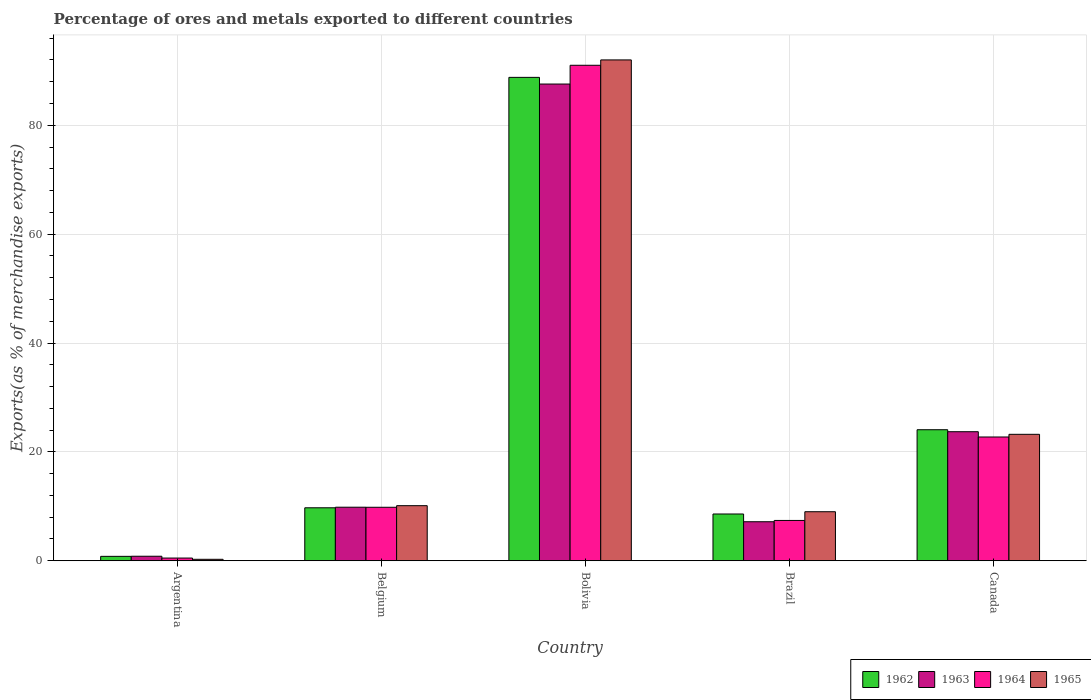How many different coloured bars are there?
Ensure brevity in your answer.  4. Are the number of bars per tick equal to the number of legend labels?
Your answer should be compact. Yes. What is the percentage of exports to different countries in 1962 in Canada?
Keep it short and to the point. 24.07. Across all countries, what is the maximum percentage of exports to different countries in 1965?
Provide a short and direct response. 92. Across all countries, what is the minimum percentage of exports to different countries in 1964?
Offer a very short reply. 0.5. In which country was the percentage of exports to different countries in 1964 minimum?
Make the answer very short. Argentina. What is the total percentage of exports to different countries in 1963 in the graph?
Make the answer very short. 129.12. What is the difference between the percentage of exports to different countries in 1962 in Belgium and that in Canada?
Offer a very short reply. -14.34. What is the difference between the percentage of exports to different countries in 1965 in Bolivia and the percentage of exports to different countries in 1962 in Argentina?
Keep it short and to the point. 91.19. What is the average percentage of exports to different countries in 1962 per country?
Provide a short and direct response. 26.4. What is the difference between the percentage of exports to different countries of/in 1962 and percentage of exports to different countries of/in 1965 in Canada?
Provide a short and direct response. 0.84. What is the ratio of the percentage of exports to different countries in 1964 in Argentina to that in Belgium?
Your response must be concise. 0.05. Is the difference between the percentage of exports to different countries in 1962 in Argentina and Brazil greater than the difference between the percentage of exports to different countries in 1965 in Argentina and Brazil?
Offer a very short reply. Yes. What is the difference between the highest and the second highest percentage of exports to different countries in 1963?
Your response must be concise. -13.87. What is the difference between the highest and the lowest percentage of exports to different countries in 1965?
Your answer should be compact. 91.73. Is the sum of the percentage of exports to different countries in 1965 in Argentina and Canada greater than the maximum percentage of exports to different countries in 1963 across all countries?
Give a very brief answer. No. Is it the case that in every country, the sum of the percentage of exports to different countries in 1962 and percentage of exports to different countries in 1964 is greater than the sum of percentage of exports to different countries in 1965 and percentage of exports to different countries in 1963?
Offer a very short reply. No. What does the 1st bar from the left in Belgium represents?
Your answer should be very brief. 1962. How many bars are there?
Your response must be concise. 20. What is the difference between two consecutive major ticks on the Y-axis?
Provide a succinct answer. 20. Does the graph contain any zero values?
Your answer should be very brief. No. How many legend labels are there?
Make the answer very short. 4. How are the legend labels stacked?
Make the answer very short. Horizontal. What is the title of the graph?
Make the answer very short. Percentage of ores and metals exported to different countries. What is the label or title of the Y-axis?
Keep it short and to the point. Exports(as % of merchandise exports). What is the Exports(as % of merchandise exports) of 1962 in Argentina?
Ensure brevity in your answer.  0.81. What is the Exports(as % of merchandise exports) in 1963 in Argentina?
Your answer should be compact. 0.83. What is the Exports(as % of merchandise exports) of 1964 in Argentina?
Your answer should be compact. 0.5. What is the Exports(as % of merchandise exports) of 1965 in Argentina?
Offer a terse response. 0.27. What is the Exports(as % of merchandise exports) in 1962 in Belgium?
Your answer should be compact. 9.73. What is the Exports(as % of merchandise exports) in 1963 in Belgium?
Provide a short and direct response. 9.84. What is the Exports(as % of merchandise exports) of 1964 in Belgium?
Offer a terse response. 9.83. What is the Exports(as % of merchandise exports) in 1965 in Belgium?
Give a very brief answer. 10.12. What is the Exports(as % of merchandise exports) in 1962 in Bolivia?
Your answer should be very brief. 88.79. What is the Exports(as % of merchandise exports) of 1963 in Bolivia?
Make the answer very short. 87.57. What is the Exports(as % of merchandise exports) of 1964 in Bolivia?
Give a very brief answer. 91.02. What is the Exports(as % of merchandise exports) of 1965 in Bolivia?
Your response must be concise. 92. What is the Exports(as % of merchandise exports) in 1962 in Brazil?
Ensure brevity in your answer.  8.59. What is the Exports(as % of merchandise exports) of 1963 in Brazil?
Offer a very short reply. 7.17. What is the Exports(as % of merchandise exports) in 1964 in Brazil?
Keep it short and to the point. 7.41. What is the Exports(as % of merchandise exports) of 1965 in Brazil?
Make the answer very short. 9.01. What is the Exports(as % of merchandise exports) in 1962 in Canada?
Make the answer very short. 24.07. What is the Exports(as % of merchandise exports) of 1963 in Canada?
Provide a succinct answer. 23.71. What is the Exports(as % of merchandise exports) of 1964 in Canada?
Ensure brevity in your answer.  22.74. What is the Exports(as % of merchandise exports) of 1965 in Canada?
Provide a succinct answer. 23.23. Across all countries, what is the maximum Exports(as % of merchandise exports) in 1962?
Ensure brevity in your answer.  88.79. Across all countries, what is the maximum Exports(as % of merchandise exports) of 1963?
Offer a very short reply. 87.57. Across all countries, what is the maximum Exports(as % of merchandise exports) in 1964?
Your response must be concise. 91.02. Across all countries, what is the maximum Exports(as % of merchandise exports) of 1965?
Keep it short and to the point. 92. Across all countries, what is the minimum Exports(as % of merchandise exports) in 1962?
Make the answer very short. 0.81. Across all countries, what is the minimum Exports(as % of merchandise exports) of 1963?
Your answer should be compact. 0.83. Across all countries, what is the minimum Exports(as % of merchandise exports) of 1964?
Provide a short and direct response. 0.5. Across all countries, what is the minimum Exports(as % of merchandise exports) in 1965?
Your answer should be compact. 0.27. What is the total Exports(as % of merchandise exports) in 1962 in the graph?
Give a very brief answer. 132. What is the total Exports(as % of merchandise exports) of 1963 in the graph?
Provide a succinct answer. 129.12. What is the total Exports(as % of merchandise exports) of 1964 in the graph?
Ensure brevity in your answer.  131.49. What is the total Exports(as % of merchandise exports) of 1965 in the graph?
Your response must be concise. 134.63. What is the difference between the Exports(as % of merchandise exports) of 1962 in Argentina and that in Belgium?
Provide a succinct answer. -8.92. What is the difference between the Exports(as % of merchandise exports) in 1963 in Argentina and that in Belgium?
Ensure brevity in your answer.  -9. What is the difference between the Exports(as % of merchandise exports) of 1964 in Argentina and that in Belgium?
Make the answer very short. -9.33. What is the difference between the Exports(as % of merchandise exports) in 1965 in Argentina and that in Belgium?
Keep it short and to the point. -9.85. What is the difference between the Exports(as % of merchandise exports) of 1962 in Argentina and that in Bolivia?
Your response must be concise. -87.98. What is the difference between the Exports(as % of merchandise exports) of 1963 in Argentina and that in Bolivia?
Keep it short and to the point. -86.74. What is the difference between the Exports(as % of merchandise exports) of 1964 in Argentina and that in Bolivia?
Offer a very short reply. -90.52. What is the difference between the Exports(as % of merchandise exports) in 1965 in Argentina and that in Bolivia?
Make the answer very short. -91.73. What is the difference between the Exports(as % of merchandise exports) of 1962 in Argentina and that in Brazil?
Offer a terse response. -7.78. What is the difference between the Exports(as % of merchandise exports) in 1963 in Argentina and that in Brazil?
Your answer should be very brief. -6.34. What is the difference between the Exports(as % of merchandise exports) in 1964 in Argentina and that in Brazil?
Give a very brief answer. -6.91. What is the difference between the Exports(as % of merchandise exports) of 1965 in Argentina and that in Brazil?
Ensure brevity in your answer.  -8.74. What is the difference between the Exports(as % of merchandise exports) of 1962 in Argentina and that in Canada?
Your response must be concise. -23.26. What is the difference between the Exports(as % of merchandise exports) in 1963 in Argentina and that in Canada?
Offer a terse response. -22.87. What is the difference between the Exports(as % of merchandise exports) in 1964 in Argentina and that in Canada?
Make the answer very short. -22.24. What is the difference between the Exports(as % of merchandise exports) in 1965 in Argentina and that in Canada?
Make the answer very short. -22.96. What is the difference between the Exports(as % of merchandise exports) in 1962 in Belgium and that in Bolivia?
Make the answer very short. -79.06. What is the difference between the Exports(as % of merchandise exports) in 1963 in Belgium and that in Bolivia?
Your response must be concise. -77.73. What is the difference between the Exports(as % of merchandise exports) of 1964 in Belgium and that in Bolivia?
Ensure brevity in your answer.  -81.19. What is the difference between the Exports(as % of merchandise exports) of 1965 in Belgium and that in Bolivia?
Offer a very short reply. -81.88. What is the difference between the Exports(as % of merchandise exports) in 1962 in Belgium and that in Brazil?
Keep it short and to the point. 1.14. What is the difference between the Exports(as % of merchandise exports) of 1963 in Belgium and that in Brazil?
Provide a short and direct response. 2.67. What is the difference between the Exports(as % of merchandise exports) of 1964 in Belgium and that in Brazil?
Keep it short and to the point. 2.42. What is the difference between the Exports(as % of merchandise exports) of 1965 in Belgium and that in Brazil?
Your answer should be very brief. 1.11. What is the difference between the Exports(as % of merchandise exports) of 1962 in Belgium and that in Canada?
Ensure brevity in your answer.  -14.34. What is the difference between the Exports(as % of merchandise exports) in 1963 in Belgium and that in Canada?
Provide a succinct answer. -13.87. What is the difference between the Exports(as % of merchandise exports) in 1964 in Belgium and that in Canada?
Keep it short and to the point. -12.91. What is the difference between the Exports(as % of merchandise exports) in 1965 in Belgium and that in Canada?
Provide a short and direct response. -13.11. What is the difference between the Exports(as % of merchandise exports) of 1962 in Bolivia and that in Brazil?
Your response must be concise. 80.2. What is the difference between the Exports(as % of merchandise exports) of 1963 in Bolivia and that in Brazil?
Make the answer very short. 80.4. What is the difference between the Exports(as % of merchandise exports) of 1964 in Bolivia and that in Brazil?
Ensure brevity in your answer.  83.61. What is the difference between the Exports(as % of merchandise exports) in 1965 in Bolivia and that in Brazil?
Provide a short and direct response. 82.99. What is the difference between the Exports(as % of merchandise exports) in 1962 in Bolivia and that in Canada?
Your answer should be compact. 64.72. What is the difference between the Exports(as % of merchandise exports) of 1963 in Bolivia and that in Canada?
Keep it short and to the point. 63.86. What is the difference between the Exports(as % of merchandise exports) of 1964 in Bolivia and that in Canada?
Your answer should be very brief. 68.28. What is the difference between the Exports(as % of merchandise exports) of 1965 in Bolivia and that in Canada?
Give a very brief answer. 68.77. What is the difference between the Exports(as % of merchandise exports) in 1962 in Brazil and that in Canada?
Your response must be concise. -15.48. What is the difference between the Exports(as % of merchandise exports) of 1963 in Brazil and that in Canada?
Offer a very short reply. -16.54. What is the difference between the Exports(as % of merchandise exports) in 1964 in Brazil and that in Canada?
Ensure brevity in your answer.  -15.33. What is the difference between the Exports(as % of merchandise exports) in 1965 in Brazil and that in Canada?
Your answer should be very brief. -14.22. What is the difference between the Exports(as % of merchandise exports) in 1962 in Argentina and the Exports(as % of merchandise exports) in 1963 in Belgium?
Provide a succinct answer. -9.02. What is the difference between the Exports(as % of merchandise exports) of 1962 in Argentina and the Exports(as % of merchandise exports) of 1964 in Belgium?
Provide a short and direct response. -9.01. What is the difference between the Exports(as % of merchandise exports) in 1962 in Argentina and the Exports(as % of merchandise exports) in 1965 in Belgium?
Give a very brief answer. -9.31. What is the difference between the Exports(as % of merchandise exports) in 1963 in Argentina and the Exports(as % of merchandise exports) in 1964 in Belgium?
Your answer should be compact. -8.99. What is the difference between the Exports(as % of merchandise exports) in 1963 in Argentina and the Exports(as % of merchandise exports) in 1965 in Belgium?
Give a very brief answer. -9.29. What is the difference between the Exports(as % of merchandise exports) of 1964 in Argentina and the Exports(as % of merchandise exports) of 1965 in Belgium?
Ensure brevity in your answer.  -9.62. What is the difference between the Exports(as % of merchandise exports) in 1962 in Argentina and the Exports(as % of merchandise exports) in 1963 in Bolivia?
Your response must be concise. -86.76. What is the difference between the Exports(as % of merchandise exports) in 1962 in Argentina and the Exports(as % of merchandise exports) in 1964 in Bolivia?
Your answer should be very brief. -90.2. What is the difference between the Exports(as % of merchandise exports) in 1962 in Argentina and the Exports(as % of merchandise exports) in 1965 in Bolivia?
Make the answer very short. -91.19. What is the difference between the Exports(as % of merchandise exports) of 1963 in Argentina and the Exports(as % of merchandise exports) of 1964 in Bolivia?
Ensure brevity in your answer.  -90.18. What is the difference between the Exports(as % of merchandise exports) of 1963 in Argentina and the Exports(as % of merchandise exports) of 1965 in Bolivia?
Your answer should be very brief. -91.17. What is the difference between the Exports(as % of merchandise exports) in 1964 in Argentina and the Exports(as % of merchandise exports) in 1965 in Bolivia?
Provide a short and direct response. -91.5. What is the difference between the Exports(as % of merchandise exports) of 1962 in Argentina and the Exports(as % of merchandise exports) of 1963 in Brazil?
Keep it short and to the point. -6.36. What is the difference between the Exports(as % of merchandise exports) of 1962 in Argentina and the Exports(as % of merchandise exports) of 1964 in Brazil?
Your answer should be very brief. -6.59. What is the difference between the Exports(as % of merchandise exports) in 1962 in Argentina and the Exports(as % of merchandise exports) in 1965 in Brazil?
Give a very brief answer. -8.2. What is the difference between the Exports(as % of merchandise exports) in 1963 in Argentina and the Exports(as % of merchandise exports) in 1964 in Brazil?
Offer a very short reply. -6.57. What is the difference between the Exports(as % of merchandise exports) in 1963 in Argentina and the Exports(as % of merchandise exports) in 1965 in Brazil?
Your answer should be very brief. -8.18. What is the difference between the Exports(as % of merchandise exports) of 1964 in Argentina and the Exports(as % of merchandise exports) of 1965 in Brazil?
Give a very brief answer. -8.51. What is the difference between the Exports(as % of merchandise exports) in 1962 in Argentina and the Exports(as % of merchandise exports) in 1963 in Canada?
Offer a terse response. -22.89. What is the difference between the Exports(as % of merchandise exports) of 1962 in Argentina and the Exports(as % of merchandise exports) of 1964 in Canada?
Provide a succinct answer. -21.92. What is the difference between the Exports(as % of merchandise exports) in 1962 in Argentina and the Exports(as % of merchandise exports) in 1965 in Canada?
Make the answer very short. -22.41. What is the difference between the Exports(as % of merchandise exports) of 1963 in Argentina and the Exports(as % of merchandise exports) of 1964 in Canada?
Provide a succinct answer. -21.9. What is the difference between the Exports(as % of merchandise exports) in 1963 in Argentina and the Exports(as % of merchandise exports) in 1965 in Canada?
Make the answer very short. -22.39. What is the difference between the Exports(as % of merchandise exports) in 1964 in Argentina and the Exports(as % of merchandise exports) in 1965 in Canada?
Keep it short and to the point. -22.73. What is the difference between the Exports(as % of merchandise exports) of 1962 in Belgium and the Exports(as % of merchandise exports) of 1963 in Bolivia?
Offer a very short reply. -77.84. What is the difference between the Exports(as % of merchandise exports) in 1962 in Belgium and the Exports(as % of merchandise exports) in 1964 in Bolivia?
Keep it short and to the point. -81.28. What is the difference between the Exports(as % of merchandise exports) in 1962 in Belgium and the Exports(as % of merchandise exports) in 1965 in Bolivia?
Your answer should be compact. -82.27. What is the difference between the Exports(as % of merchandise exports) of 1963 in Belgium and the Exports(as % of merchandise exports) of 1964 in Bolivia?
Keep it short and to the point. -81.18. What is the difference between the Exports(as % of merchandise exports) of 1963 in Belgium and the Exports(as % of merchandise exports) of 1965 in Bolivia?
Offer a very short reply. -82.16. What is the difference between the Exports(as % of merchandise exports) of 1964 in Belgium and the Exports(as % of merchandise exports) of 1965 in Bolivia?
Give a very brief answer. -82.17. What is the difference between the Exports(as % of merchandise exports) of 1962 in Belgium and the Exports(as % of merchandise exports) of 1963 in Brazil?
Your answer should be very brief. 2.56. What is the difference between the Exports(as % of merchandise exports) of 1962 in Belgium and the Exports(as % of merchandise exports) of 1964 in Brazil?
Your answer should be compact. 2.33. What is the difference between the Exports(as % of merchandise exports) of 1962 in Belgium and the Exports(as % of merchandise exports) of 1965 in Brazil?
Keep it short and to the point. 0.72. What is the difference between the Exports(as % of merchandise exports) in 1963 in Belgium and the Exports(as % of merchandise exports) in 1964 in Brazil?
Your answer should be compact. 2.43. What is the difference between the Exports(as % of merchandise exports) in 1963 in Belgium and the Exports(as % of merchandise exports) in 1965 in Brazil?
Offer a very short reply. 0.83. What is the difference between the Exports(as % of merchandise exports) of 1964 in Belgium and the Exports(as % of merchandise exports) of 1965 in Brazil?
Give a very brief answer. 0.82. What is the difference between the Exports(as % of merchandise exports) in 1962 in Belgium and the Exports(as % of merchandise exports) in 1963 in Canada?
Give a very brief answer. -13.97. What is the difference between the Exports(as % of merchandise exports) in 1962 in Belgium and the Exports(as % of merchandise exports) in 1964 in Canada?
Provide a short and direct response. -13. What is the difference between the Exports(as % of merchandise exports) of 1962 in Belgium and the Exports(as % of merchandise exports) of 1965 in Canada?
Provide a succinct answer. -13.49. What is the difference between the Exports(as % of merchandise exports) in 1963 in Belgium and the Exports(as % of merchandise exports) in 1964 in Canada?
Keep it short and to the point. -12.9. What is the difference between the Exports(as % of merchandise exports) in 1963 in Belgium and the Exports(as % of merchandise exports) in 1965 in Canada?
Provide a succinct answer. -13.39. What is the difference between the Exports(as % of merchandise exports) in 1964 in Belgium and the Exports(as % of merchandise exports) in 1965 in Canada?
Offer a terse response. -13.4. What is the difference between the Exports(as % of merchandise exports) of 1962 in Bolivia and the Exports(as % of merchandise exports) of 1963 in Brazil?
Give a very brief answer. 81.62. What is the difference between the Exports(as % of merchandise exports) in 1962 in Bolivia and the Exports(as % of merchandise exports) in 1964 in Brazil?
Your answer should be compact. 81.39. What is the difference between the Exports(as % of merchandise exports) of 1962 in Bolivia and the Exports(as % of merchandise exports) of 1965 in Brazil?
Make the answer very short. 79.78. What is the difference between the Exports(as % of merchandise exports) of 1963 in Bolivia and the Exports(as % of merchandise exports) of 1964 in Brazil?
Make the answer very short. 80.16. What is the difference between the Exports(as % of merchandise exports) in 1963 in Bolivia and the Exports(as % of merchandise exports) in 1965 in Brazil?
Make the answer very short. 78.56. What is the difference between the Exports(as % of merchandise exports) of 1964 in Bolivia and the Exports(as % of merchandise exports) of 1965 in Brazil?
Make the answer very short. 82.01. What is the difference between the Exports(as % of merchandise exports) in 1962 in Bolivia and the Exports(as % of merchandise exports) in 1963 in Canada?
Offer a very short reply. 65.09. What is the difference between the Exports(as % of merchandise exports) of 1962 in Bolivia and the Exports(as % of merchandise exports) of 1964 in Canada?
Your answer should be very brief. 66.06. What is the difference between the Exports(as % of merchandise exports) in 1962 in Bolivia and the Exports(as % of merchandise exports) in 1965 in Canada?
Provide a succinct answer. 65.57. What is the difference between the Exports(as % of merchandise exports) in 1963 in Bolivia and the Exports(as % of merchandise exports) in 1964 in Canada?
Provide a succinct answer. 64.83. What is the difference between the Exports(as % of merchandise exports) of 1963 in Bolivia and the Exports(as % of merchandise exports) of 1965 in Canada?
Your response must be concise. 64.34. What is the difference between the Exports(as % of merchandise exports) of 1964 in Bolivia and the Exports(as % of merchandise exports) of 1965 in Canada?
Your answer should be compact. 67.79. What is the difference between the Exports(as % of merchandise exports) of 1962 in Brazil and the Exports(as % of merchandise exports) of 1963 in Canada?
Your response must be concise. -15.11. What is the difference between the Exports(as % of merchandise exports) of 1962 in Brazil and the Exports(as % of merchandise exports) of 1964 in Canada?
Your answer should be compact. -14.15. What is the difference between the Exports(as % of merchandise exports) in 1962 in Brazil and the Exports(as % of merchandise exports) in 1965 in Canada?
Your response must be concise. -14.64. What is the difference between the Exports(as % of merchandise exports) of 1963 in Brazil and the Exports(as % of merchandise exports) of 1964 in Canada?
Keep it short and to the point. -15.57. What is the difference between the Exports(as % of merchandise exports) of 1963 in Brazil and the Exports(as % of merchandise exports) of 1965 in Canada?
Provide a short and direct response. -16.06. What is the difference between the Exports(as % of merchandise exports) in 1964 in Brazil and the Exports(as % of merchandise exports) in 1965 in Canada?
Your answer should be very brief. -15.82. What is the average Exports(as % of merchandise exports) in 1962 per country?
Your response must be concise. 26.4. What is the average Exports(as % of merchandise exports) of 1963 per country?
Offer a very short reply. 25.82. What is the average Exports(as % of merchandise exports) in 1964 per country?
Give a very brief answer. 26.3. What is the average Exports(as % of merchandise exports) of 1965 per country?
Your response must be concise. 26.93. What is the difference between the Exports(as % of merchandise exports) in 1962 and Exports(as % of merchandise exports) in 1963 in Argentina?
Give a very brief answer. -0.02. What is the difference between the Exports(as % of merchandise exports) of 1962 and Exports(as % of merchandise exports) of 1964 in Argentina?
Give a very brief answer. 0.31. What is the difference between the Exports(as % of merchandise exports) of 1962 and Exports(as % of merchandise exports) of 1965 in Argentina?
Your answer should be compact. 0.54. What is the difference between the Exports(as % of merchandise exports) of 1963 and Exports(as % of merchandise exports) of 1964 in Argentina?
Ensure brevity in your answer.  0.33. What is the difference between the Exports(as % of merchandise exports) of 1963 and Exports(as % of merchandise exports) of 1965 in Argentina?
Provide a short and direct response. 0.56. What is the difference between the Exports(as % of merchandise exports) of 1964 and Exports(as % of merchandise exports) of 1965 in Argentina?
Give a very brief answer. 0.23. What is the difference between the Exports(as % of merchandise exports) in 1962 and Exports(as % of merchandise exports) in 1963 in Belgium?
Give a very brief answer. -0.1. What is the difference between the Exports(as % of merchandise exports) of 1962 and Exports(as % of merchandise exports) of 1964 in Belgium?
Your answer should be very brief. -0.09. What is the difference between the Exports(as % of merchandise exports) of 1962 and Exports(as % of merchandise exports) of 1965 in Belgium?
Your answer should be compact. -0.39. What is the difference between the Exports(as % of merchandise exports) in 1963 and Exports(as % of merchandise exports) in 1964 in Belgium?
Provide a succinct answer. 0.01. What is the difference between the Exports(as % of merchandise exports) of 1963 and Exports(as % of merchandise exports) of 1965 in Belgium?
Keep it short and to the point. -0.28. What is the difference between the Exports(as % of merchandise exports) of 1964 and Exports(as % of merchandise exports) of 1965 in Belgium?
Provide a short and direct response. -0.29. What is the difference between the Exports(as % of merchandise exports) of 1962 and Exports(as % of merchandise exports) of 1963 in Bolivia?
Ensure brevity in your answer.  1.22. What is the difference between the Exports(as % of merchandise exports) in 1962 and Exports(as % of merchandise exports) in 1964 in Bolivia?
Give a very brief answer. -2.22. What is the difference between the Exports(as % of merchandise exports) of 1962 and Exports(as % of merchandise exports) of 1965 in Bolivia?
Provide a succinct answer. -3.21. What is the difference between the Exports(as % of merchandise exports) in 1963 and Exports(as % of merchandise exports) in 1964 in Bolivia?
Ensure brevity in your answer.  -3.45. What is the difference between the Exports(as % of merchandise exports) in 1963 and Exports(as % of merchandise exports) in 1965 in Bolivia?
Provide a short and direct response. -4.43. What is the difference between the Exports(as % of merchandise exports) in 1964 and Exports(as % of merchandise exports) in 1965 in Bolivia?
Ensure brevity in your answer.  -0.98. What is the difference between the Exports(as % of merchandise exports) in 1962 and Exports(as % of merchandise exports) in 1963 in Brazil?
Keep it short and to the point. 1.42. What is the difference between the Exports(as % of merchandise exports) of 1962 and Exports(as % of merchandise exports) of 1964 in Brazil?
Your response must be concise. 1.18. What is the difference between the Exports(as % of merchandise exports) in 1962 and Exports(as % of merchandise exports) in 1965 in Brazil?
Offer a terse response. -0.42. What is the difference between the Exports(as % of merchandise exports) of 1963 and Exports(as % of merchandise exports) of 1964 in Brazil?
Offer a terse response. -0.24. What is the difference between the Exports(as % of merchandise exports) in 1963 and Exports(as % of merchandise exports) in 1965 in Brazil?
Keep it short and to the point. -1.84. What is the difference between the Exports(as % of merchandise exports) in 1964 and Exports(as % of merchandise exports) in 1965 in Brazil?
Provide a succinct answer. -1.6. What is the difference between the Exports(as % of merchandise exports) of 1962 and Exports(as % of merchandise exports) of 1963 in Canada?
Provide a succinct answer. 0.37. What is the difference between the Exports(as % of merchandise exports) of 1962 and Exports(as % of merchandise exports) of 1964 in Canada?
Your answer should be very brief. 1.33. What is the difference between the Exports(as % of merchandise exports) in 1962 and Exports(as % of merchandise exports) in 1965 in Canada?
Give a very brief answer. 0.84. What is the difference between the Exports(as % of merchandise exports) in 1963 and Exports(as % of merchandise exports) in 1964 in Canada?
Give a very brief answer. 0.97. What is the difference between the Exports(as % of merchandise exports) of 1963 and Exports(as % of merchandise exports) of 1965 in Canada?
Keep it short and to the point. 0.48. What is the difference between the Exports(as % of merchandise exports) in 1964 and Exports(as % of merchandise exports) in 1965 in Canada?
Provide a succinct answer. -0.49. What is the ratio of the Exports(as % of merchandise exports) in 1962 in Argentina to that in Belgium?
Provide a succinct answer. 0.08. What is the ratio of the Exports(as % of merchandise exports) in 1963 in Argentina to that in Belgium?
Offer a terse response. 0.08. What is the ratio of the Exports(as % of merchandise exports) of 1964 in Argentina to that in Belgium?
Your answer should be very brief. 0.05. What is the ratio of the Exports(as % of merchandise exports) of 1965 in Argentina to that in Belgium?
Give a very brief answer. 0.03. What is the ratio of the Exports(as % of merchandise exports) in 1962 in Argentina to that in Bolivia?
Your answer should be compact. 0.01. What is the ratio of the Exports(as % of merchandise exports) in 1963 in Argentina to that in Bolivia?
Provide a short and direct response. 0.01. What is the ratio of the Exports(as % of merchandise exports) of 1964 in Argentina to that in Bolivia?
Offer a very short reply. 0.01. What is the ratio of the Exports(as % of merchandise exports) of 1965 in Argentina to that in Bolivia?
Ensure brevity in your answer.  0. What is the ratio of the Exports(as % of merchandise exports) in 1962 in Argentina to that in Brazil?
Your response must be concise. 0.09. What is the ratio of the Exports(as % of merchandise exports) of 1963 in Argentina to that in Brazil?
Ensure brevity in your answer.  0.12. What is the ratio of the Exports(as % of merchandise exports) of 1964 in Argentina to that in Brazil?
Provide a succinct answer. 0.07. What is the ratio of the Exports(as % of merchandise exports) of 1965 in Argentina to that in Brazil?
Make the answer very short. 0.03. What is the ratio of the Exports(as % of merchandise exports) in 1962 in Argentina to that in Canada?
Keep it short and to the point. 0.03. What is the ratio of the Exports(as % of merchandise exports) of 1963 in Argentina to that in Canada?
Your response must be concise. 0.04. What is the ratio of the Exports(as % of merchandise exports) in 1964 in Argentina to that in Canada?
Provide a short and direct response. 0.02. What is the ratio of the Exports(as % of merchandise exports) of 1965 in Argentina to that in Canada?
Your response must be concise. 0.01. What is the ratio of the Exports(as % of merchandise exports) in 1962 in Belgium to that in Bolivia?
Your answer should be very brief. 0.11. What is the ratio of the Exports(as % of merchandise exports) of 1963 in Belgium to that in Bolivia?
Your response must be concise. 0.11. What is the ratio of the Exports(as % of merchandise exports) of 1964 in Belgium to that in Bolivia?
Your answer should be very brief. 0.11. What is the ratio of the Exports(as % of merchandise exports) in 1965 in Belgium to that in Bolivia?
Provide a succinct answer. 0.11. What is the ratio of the Exports(as % of merchandise exports) in 1962 in Belgium to that in Brazil?
Keep it short and to the point. 1.13. What is the ratio of the Exports(as % of merchandise exports) in 1963 in Belgium to that in Brazil?
Your answer should be very brief. 1.37. What is the ratio of the Exports(as % of merchandise exports) in 1964 in Belgium to that in Brazil?
Offer a terse response. 1.33. What is the ratio of the Exports(as % of merchandise exports) in 1965 in Belgium to that in Brazil?
Keep it short and to the point. 1.12. What is the ratio of the Exports(as % of merchandise exports) of 1962 in Belgium to that in Canada?
Give a very brief answer. 0.4. What is the ratio of the Exports(as % of merchandise exports) in 1963 in Belgium to that in Canada?
Provide a succinct answer. 0.41. What is the ratio of the Exports(as % of merchandise exports) in 1964 in Belgium to that in Canada?
Your response must be concise. 0.43. What is the ratio of the Exports(as % of merchandise exports) in 1965 in Belgium to that in Canada?
Offer a terse response. 0.44. What is the ratio of the Exports(as % of merchandise exports) in 1962 in Bolivia to that in Brazil?
Provide a short and direct response. 10.33. What is the ratio of the Exports(as % of merchandise exports) in 1963 in Bolivia to that in Brazil?
Offer a very short reply. 12.21. What is the ratio of the Exports(as % of merchandise exports) in 1964 in Bolivia to that in Brazil?
Ensure brevity in your answer.  12.29. What is the ratio of the Exports(as % of merchandise exports) of 1965 in Bolivia to that in Brazil?
Offer a very short reply. 10.21. What is the ratio of the Exports(as % of merchandise exports) in 1962 in Bolivia to that in Canada?
Make the answer very short. 3.69. What is the ratio of the Exports(as % of merchandise exports) of 1963 in Bolivia to that in Canada?
Provide a succinct answer. 3.69. What is the ratio of the Exports(as % of merchandise exports) in 1964 in Bolivia to that in Canada?
Provide a short and direct response. 4. What is the ratio of the Exports(as % of merchandise exports) of 1965 in Bolivia to that in Canada?
Ensure brevity in your answer.  3.96. What is the ratio of the Exports(as % of merchandise exports) in 1962 in Brazil to that in Canada?
Provide a short and direct response. 0.36. What is the ratio of the Exports(as % of merchandise exports) in 1963 in Brazil to that in Canada?
Provide a short and direct response. 0.3. What is the ratio of the Exports(as % of merchandise exports) in 1964 in Brazil to that in Canada?
Your answer should be compact. 0.33. What is the ratio of the Exports(as % of merchandise exports) in 1965 in Brazil to that in Canada?
Your answer should be compact. 0.39. What is the difference between the highest and the second highest Exports(as % of merchandise exports) of 1962?
Offer a terse response. 64.72. What is the difference between the highest and the second highest Exports(as % of merchandise exports) of 1963?
Offer a very short reply. 63.86. What is the difference between the highest and the second highest Exports(as % of merchandise exports) of 1964?
Your response must be concise. 68.28. What is the difference between the highest and the second highest Exports(as % of merchandise exports) in 1965?
Make the answer very short. 68.77. What is the difference between the highest and the lowest Exports(as % of merchandise exports) of 1962?
Provide a short and direct response. 87.98. What is the difference between the highest and the lowest Exports(as % of merchandise exports) in 1963?
Provide a short and direct response. 86.74. What is the difference between the highest and the lowest Exports(as % of merchandise exports) of 1964?
Ensure brevity in your answer.  90.52. What is the difference between the highest and the lowest Exports(as % of merchandise exports) of 1965?
Your response must be concise. 91.73. 